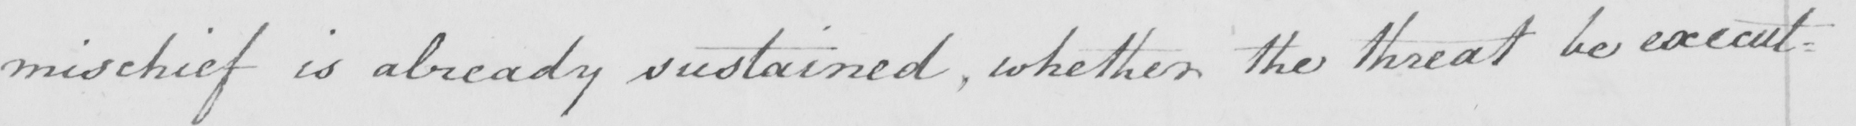What is written in this line of handwriting? mischief is already sustained , whether the threat be execut : 